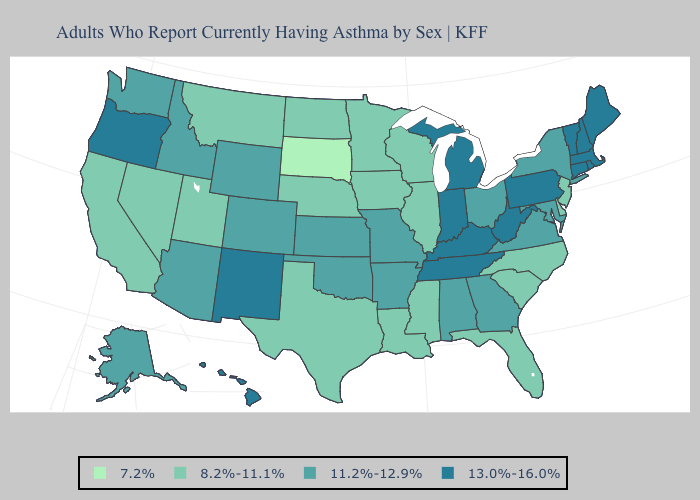How many symbols are there in the legend?
Be succinct. 4. Does the map have missing data?
Answer briefly. No. What is the value of Arizona?
Keep it brief. 11.2%-12.9%. Which states have the lowest value in the USA?
Write a very short answer. South Dakota. What is the highest value in the South ?
Short answer required. 13.0%-16.0%. Does Missouri have a higher value than Connecticut?
Write a very short answer. No. What is the value of Louisiana?
Be succinct. 8.2%-11.1%. Does South Dakota have the lowest value in the USA?
Answer briefly. Yes. Name the states that have a value in the range 13.0%-16.0%?
Short answer required. Connecticut, Hawaii, Indiana, Kentucky, Maine, Massachusetts, Michigan, New Hampshire, New Mexico, Oregon, Pennsylvania, Rhode Island, Tennessee, Vermont, West Virginia. Does New Jersey have the highest value in the Northeast?
Concise answer only. No. Name the states that have a value in the range 11.2%-12.9%?
Be succinct. Alabama, Alaska, Arizona, Arkansas, Colorado, Georgia, Idaho, Kansas, Maryland, Missouri, New York, Ohio, Oklahoma, Virginia, Washington, Wyoming. Does Texas have a lower value than South Carolina?
Keep it brief. No. What is the value of Montana?
Write a very short answer. 8.2%-11.1%. Which states hav the highest value in the West?
Keep it brief. Hawaii, New Mexico, Oregon. What is the value of North Dakota?
Be succinct. 8.2%-11.1%. 